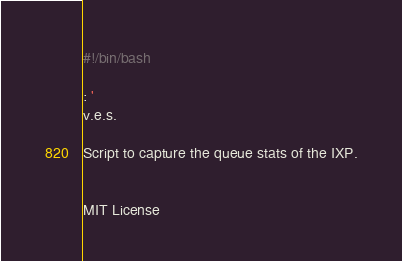Convert code to text. <code><loc_0><loc_0><loc_500><loc_500><_Bash_>#!/bin/bash

: ' 
v.e.s.

Script to capture the queue stats of the IXP.


MIT License
</code> 